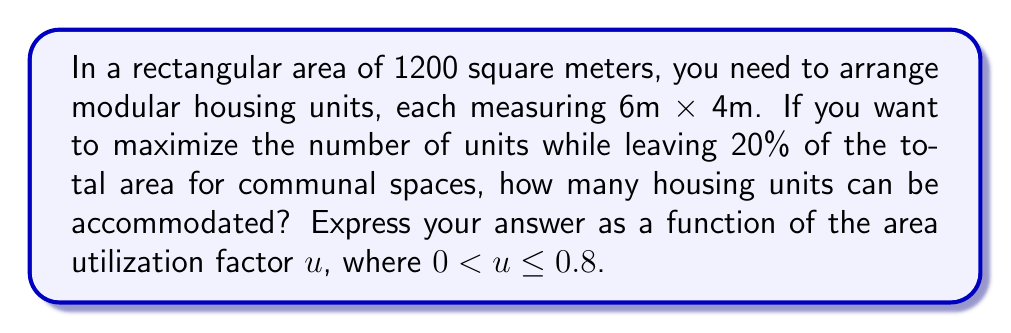Help me with this question. Let's approach this step-by-step:

1) First, we need to calculate the area available for housing units:
   Available area = Total area × (1 - Communal space percentage)
   Available area = 1200 × (1 - 0.2) = 1200 × 0.8 = 960 m²

2) Now, let's introduce the utilization factor $u$. This factor represents the proportion of the available area that can actually be used for housing units, considering practical constraints. The maximum value of $u$ is 0.8, as 20% is reserved for communal spaces.

3) The actual area used for housing = Available area × $u$ = 960$u$ m²

4) Each housing unit occupies:
   Unit area = 6m × 4m = 24 m²

5) To find the number of units, we divide the actual area used by the area of each unit:
   Number of units = $\frac{\text{Actual area used}}{\text{Unit area}}$

6) Expressing this as a function:
   $f(u) = \frac{960u}{24} = 40u$

7) Since we can only have whole numbers of housing units, we need to floor this function:
   $f(u) = \lfloor 40u \rfloor$

Where $\lfloor \rfloor$ represents the floor function (rounding down to the nearest integer).
Answer: $f(u) = \lfloor 40u \rfloor$, where $0 < u \leq 0.8$ 